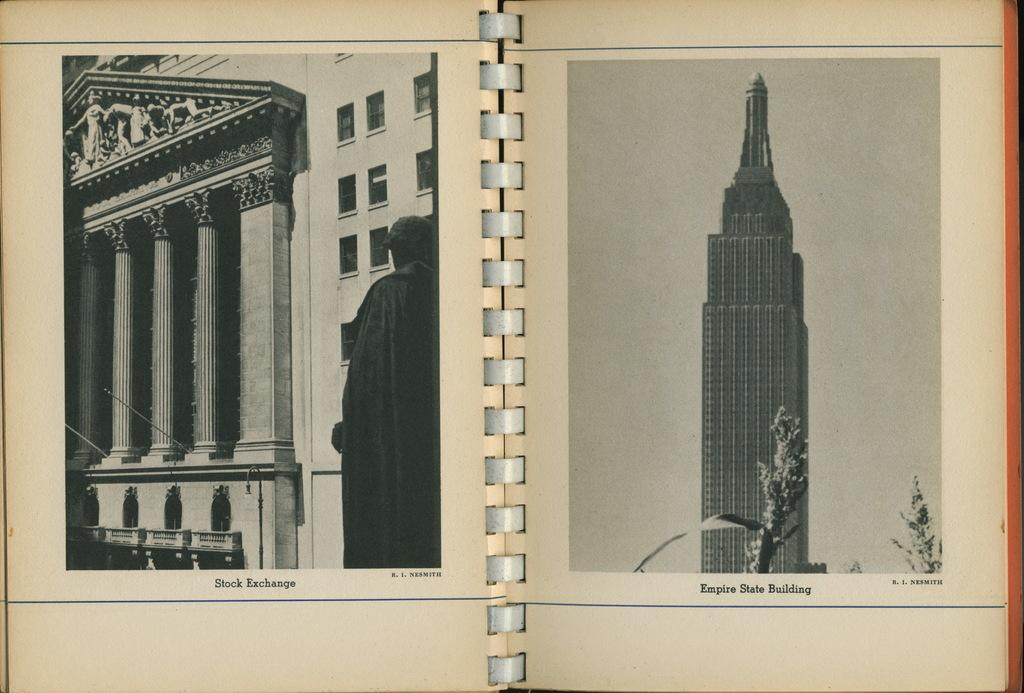What is located in the foreground of the image? There is a book in the foreground of the image. What is the state of the book in the image? The book is opened. What can be seen on the pages of the book? There are two images on the book. What type of engine can be seen powering the book in the image? There is no engine present in the image; it is a book with two images. How does the wrist of the person holding the book look like in the image? There is no person holding the book in the image, as it is placed in the foreground. 